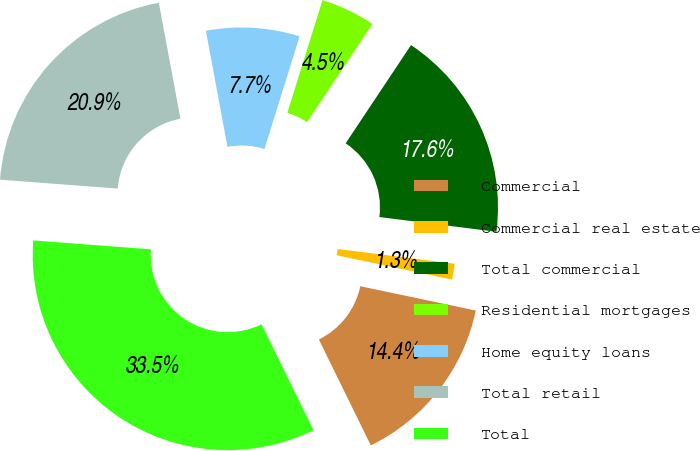Convert chart. <chart><loc_0><loc_0><loc_500><loc_500><pie_chart><fcel>Commercial<fcel>Commercial real estate<fcel>Total commercial<fcel>Residential mortgages<fcel>Home equity loans<fcel>Total retail<fcel>Total<nl><fcel>14.44%<fcel>1.31%<fcel>17.65%<fcel>4.53%<fcel>7.74%<fcel>20.87%<fcel>33.46%<nl></chart> 